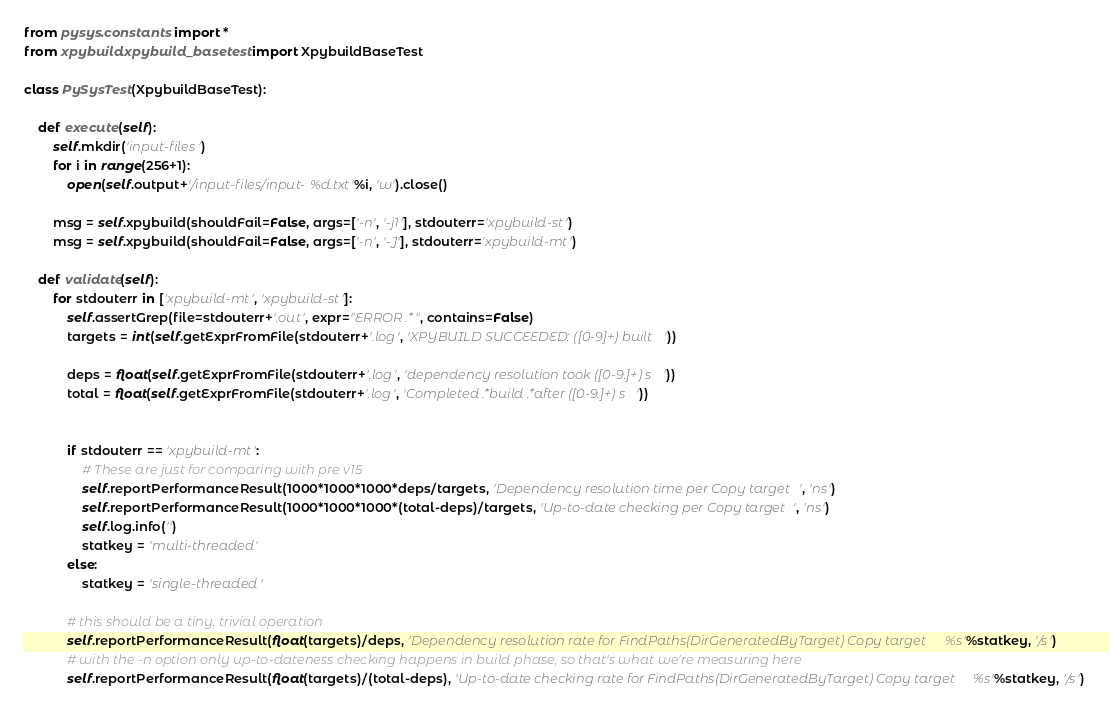<code> <loc_0><loc_0><loc_500><loc_500><_Python_>from pysys.constants import *
from xpybuild.xpybuild_basetest import XpybuildBaseTest

class PySysTest(XpybuildBaseTest):

	def execute(self):
		self.mkdir('input-files')
		for i in range(256+1):
			open(self.output+'/input-files/input-%d.txt'%i, 'w').close()
		
		msg = self.xpybuild(shouldFail=False, args=['-n', '-j1'], stdouterr='xpybuild-st')
		msg = self.xpybuild(shouldFail=False, args=['-n', '-J'], stdouterr='xpybuild-mt')

	def validate(self):
		for stdouterr in ['xpybuild-mt', 'xpybuild-st']:
			self.assertGrep(file=stdouterr+'.out', expr="ERROR .*", contains=False)
			targets = int(self.getExprFromFile(stdouterr+'.log', 'XPYBUILD SUCCEEDED: ([0-9]+) built '))
			
			deps = float(self.getExprFromFile(stdouterr+'.log', 'dependency resolution took ([0-9.]+) s'))
			total = float(self.getExprFromFile(stdouterr+'.log', 'Completed .*build .*after ([0-9.]+) s'))

			
			if stdouterr == 'xpybuild-mt':
				# These are just for comparing with pre v15
				self.reportPerformanceResult(1000*1000*1000*deps/targets, 'Dependency resolution time per Copy target', 'ns')
				self.reportPerformanceResult(1000*1000*1000*(total-deps)/targets, 'Up-to-date checking per Copy target', 'ns')
				self.log.info('')
				statkey = 'multi-threaded'
			else:
				statkey = 'single-threaded'

			# this should be a tiny, trivial operation
			self.reportPerformanceResult(float(targets)/deps, 'Dependency resolution rate for FindPaths(DirGeneratedByTarget) Copy target %s'%statkey, '/s')
			# with the -n option only up-to-dateness checking happens in build phase, so that's what we're measuring here
			self.reportPerformanceResult(float(targets)/(total-deps), 'Up-to-date checking rate for FindPaths(DirGeneratedByTarget) Copy target %s'%statkey, '/s')

</code> 